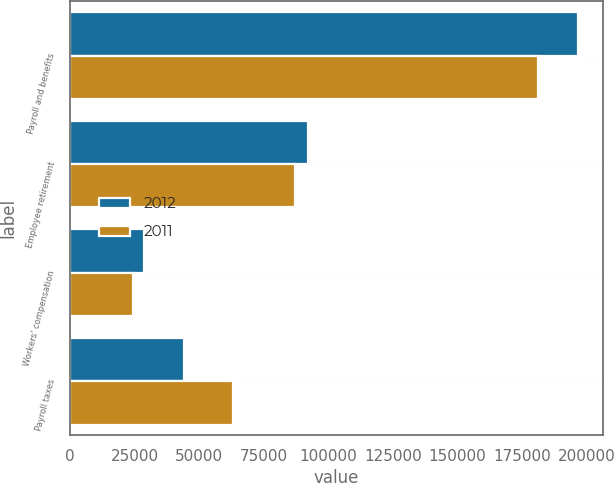Convert chart to OTSL. <chart><loc_0><loc_0><loc_500><loc_500><stacked_bar_chart><ecel><fcel>Payroll and benefits<fcel>Employee retirement<fcel>Workers' compensation<fcel>Payroll taxes<nl><fcel>2012<fcel>196569<fcel>92233<fcel>28595<fcel>44244<nl><fcel>2011<fcel>181035<fcel>87031<fcel>24217<fcel>63011<nl></chart> 